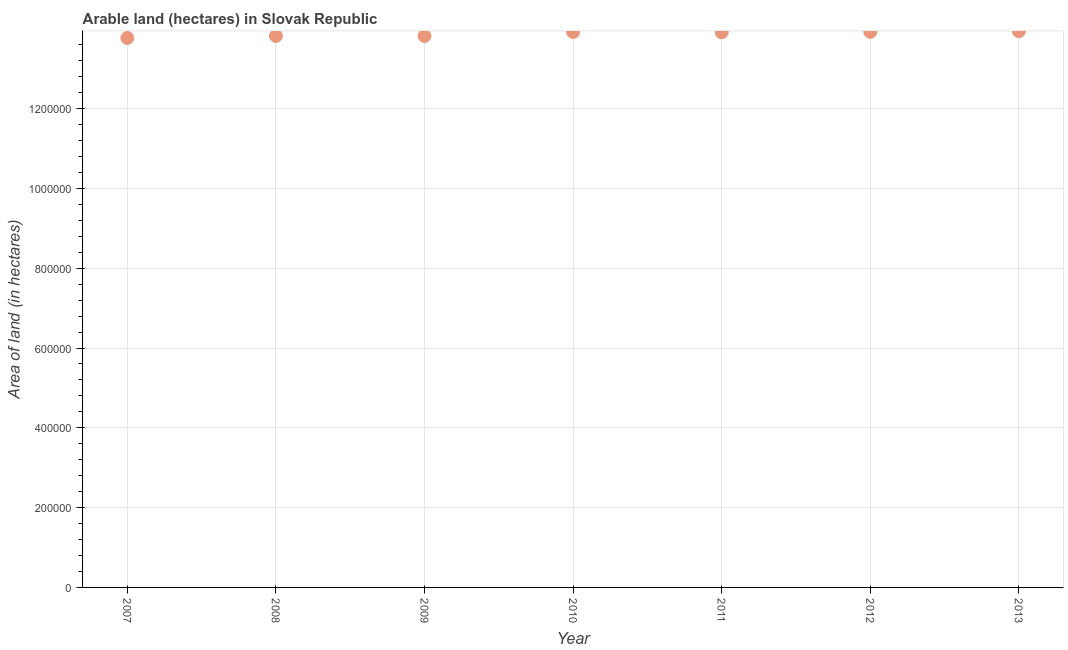What is the area of land in 2010?
Your response must be concise. 1.39e+06. Across all years, what is the maximum area of land?
Make the answer very short. 1.39e+06. Across all years, what is the minimum area of land?
Give a very brief answer. 1.38e+06. In which year was the area of land maximum?
Offer a terse response. 2013. What is the sum of the area of land?
Offer a terse response. 9.71e+06. What is the difference between the area of land in 2009 and 2013?
Offer a very short reply. -1.20e+04. What is the average area of land per year?
Ensure brevity in your answer.  1.39e+06. What is the median area of land?
Offer a terse response. 1.39e+06. What is the ratio of the area of land in 2009 to that in 2013?
Your response must be concise. 0.99. Is the difference between the area of land in 2008 and 2009 greater than the difference between any two years?
Offer a very short reply. No. What is the difference between the highest and the second highest area of land?
Ensure brevity in your answer.  1700. What is the difference between the highest and the lowest area of land?
Offer a terse response. 1.70e+04. Does the area of land monotonically increase over the years?
Your answer should be very brief. No. How many dotlines are there?
Provide a succinct answer. 1. What is the difference between two consecutive major ticks on the Y-axis?
Provide a short and direct response. 2.00e+05. Does the graph contain any zero values?
Your response must be concise. No. What is the title of the graph?
Keep it short and to the point. Arable land (hectares) in Slovak Republic. What is the label or title of the Y-axis?
Ensure brevity in your answer.  Area of land (in hectares). What is the Area of land (in hectares) in 2007?
Your answer should be very brief. 1.38e+06. What is the Area of land (in hectares) in 2008?
Make the answer very short. 1.38e+06. What is the Area of land (in hectares) in 2009?
Offer a terse response. 1.38e+06. What is the Area of land (in hectares) in 2010?
Keep it short and to the point. 1.39e+06. What is the Area of land (in hectares) in 2011?
Ensure brevity in your answer.  1.39e+06. What is the Area of land (in hectares) in 2012?
Provide a succinct answer. 1.39e+06. What is the Area of land (in hectares) in 2013?
Keep it short and to the point. 1.39e+06. What is the difference between the Area of land (in hectares) in 2007 and 2008?
Make the answer very short. -5000. What is the difference between the Area of land (in hectares) in 2007 and 2009?
Offer a terse response. -5000. What is the difference between the Area of land (in hectares) in 2007 and 2010?
Offer a terse response. -1.50e+04. What is the difference between the Area of land (in hectares) in 2007 and 2011?
Your answer should be compact. -1.42e+04. What is the difference between the Area of land (in hectares) in 2007 and 2012?
Give a very brief answer. -1.53e+04. What is the difference between the Area of land (in hectares) in 2007 and 2013?
Your response must be concise. -1.70e+04. What is the difference between the Area of land (in hectares) in 2008 and 2009?
Ensure brevity in your answer.  0. What is the difference between the Area of land (in hectares) in 2008 and 2010?
Your answer should be compact. -10000. What is the difference between the Area of land (in hectares) in 2008 and 2011?
Your answer should be compact. -9200. What is the difference between the Area of land (in hectares) in 2008 and 2012?
Give a very brief answer. -1.03e+04. What is the difference between the Area of land (in hectares) in 2008 and 2013?
Offer a terse response. -1.20e+04. What is the difference between the Area of land (in hectares) in 2009 and 2010?
Your response must be concise. -10000. What is the difference between the Area of land (in hectares) in 2009 and 2011?
Ensure brevity in your answer.  -9200. What is the difference between the Area of land (in hectares) in 2009 and 2012?
Your response must be concise. -1.03e+04. What is the difference between the Area of land (in hectares) in 2009 and 2013?
Provide a short and direct response. -1.20e+04. What is the difference between the Area of land (in hectares) in 2010 and 2011?
Your response must be concise. 800. What is the difference between the Area of land (in hectares) in 2010 and 2012?
Ensure brevity in your answer.  -300. What is the difference between the Area of land (in hectares) in 2010 and 2013?
Provide a short and direct response. -2000. What is the difference between the Area of land (in hectares) in 2011 and 2012?
Make the answer very short. -1100. What is the difference between the Area of land (in hectares) in 2011 and 2013?
Make the answer very short. -2800. What is the difference between the Area of land (in hectares) in 2012 and 2013?
Ensure brevity in your answer.  -1700. What is the ratio of the Area of land (in hectares) in 2007 to that in 2008?
Offer a very short reply. 1. What is the ratio of the Area of land (in hectares) in 2007 to that in 2009?
Provide a short and direct response. 1. What is the ratio of the Area of land (in hectares) in 2007 to that in 2010?
Keep it short and to the point. 0.99. What is the ratio of the Area of land (in hectares) in 2007 to that in 2011?
Offer a terse response. 0.99. What is the ratio of the Area of land (in hectares) in 2008 to that in 2009?
Your answer should be compact. 1. What is the ratio of the Area of land (in hectares) in 2008 to that in 2010?
Ensure brevity in your answer.  0.99. What is the ratio of the Area of land (in hectares) in 2008 to that in 2011?
Keep it short and to the point. 0.99. What is the ratio of the Area of land (in hectares) in 2008 to that in 2012?
Keep it short and to the point. 0.99. What is the ratio of the Area of land (in hectares) in 2008 to that in 2013?
Provide a short and direct response. 0.99. What is the ratio of the Area of land (in hectares) in 2009 to that in 2012?
Your response must be concise. 0.99. What is the ratio of the Area of land (in hectares) in 2010 to that in 2011?
Provide a short and direct response. 1. What is the ratio of the Area of land (in hectares) in 2011 to that in 2012?
Keep it short and to the point. 1. 